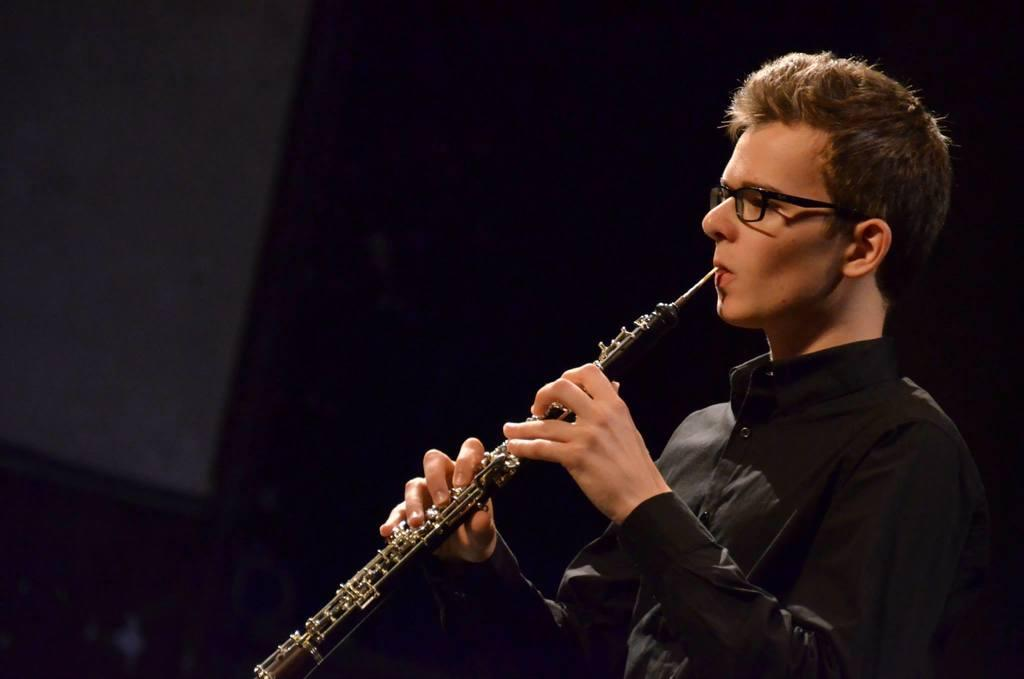What is the main subject of the image? There is a person in the image. What is the person doing in the image? The person is playing a clarinet. Can you describe the background of the image? The background of the image is dark. How many fairies are playing bells in the image? There are no fairies or bells present in the image. What type of alarm can be heard in the image? There is no alarm present in the image, as it is a still image and cannot produce sound. 